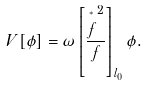Convert formula to latex. <formula><loc_0><loc_0><loc_500><loc_500>V [ \phi ] = \omega \left [ \frac { \overset { ^ { * } } { f } ^ { 2 } } { f } \right ] _ { l _ { 0 } } \phi .</formula> 